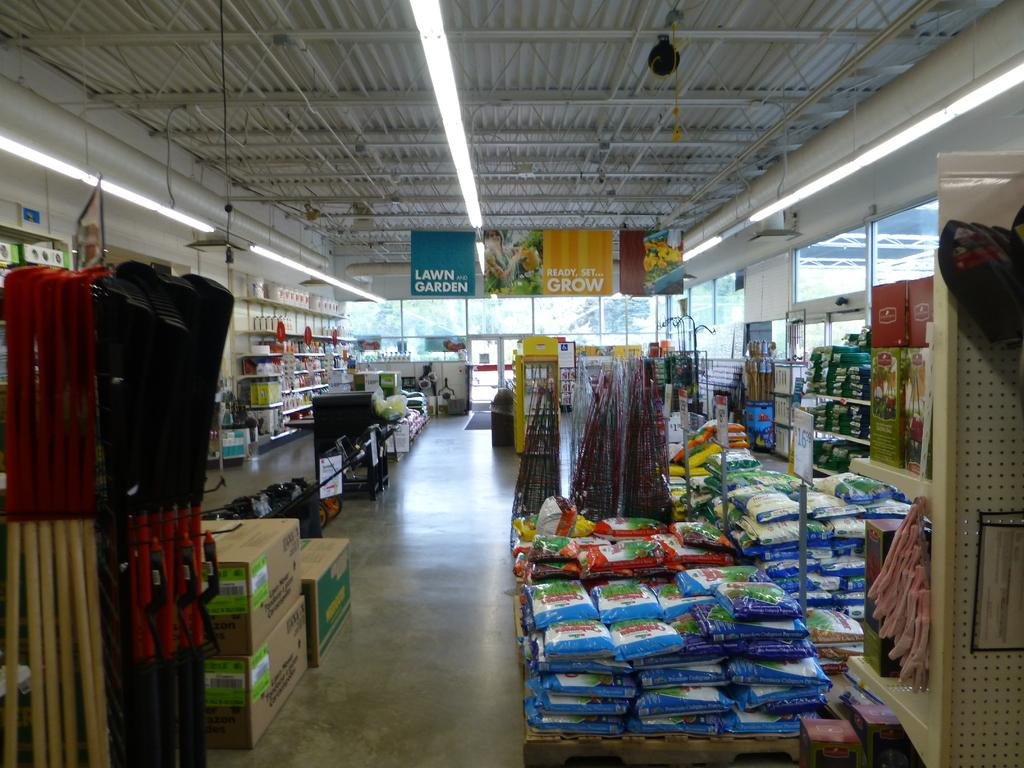<image>
Present a compact description of the photo's key features. an interior of a shop with signs for LAWN and GARDEN 